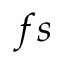Convert formula to latex. <formula><loc_0><loc_0><loc_500><loc_500>f s</formula> 